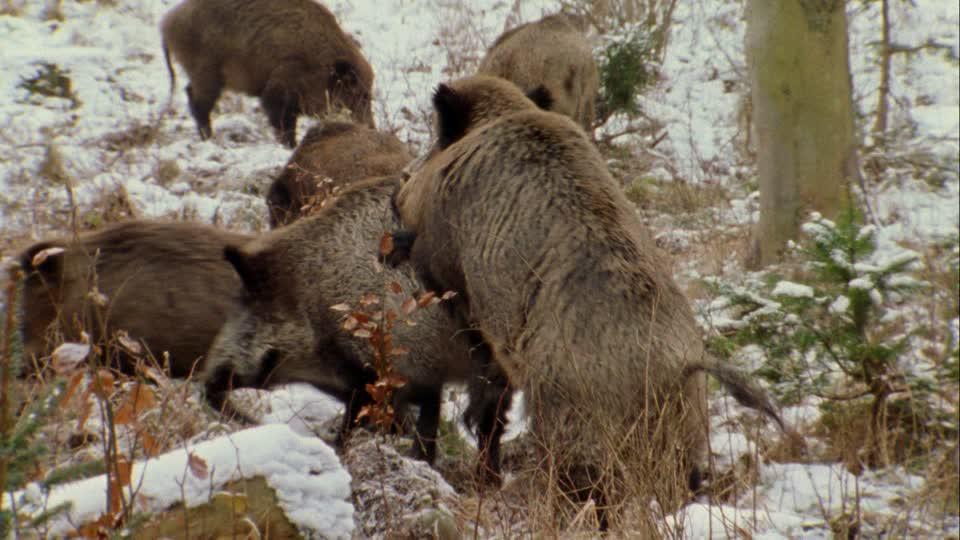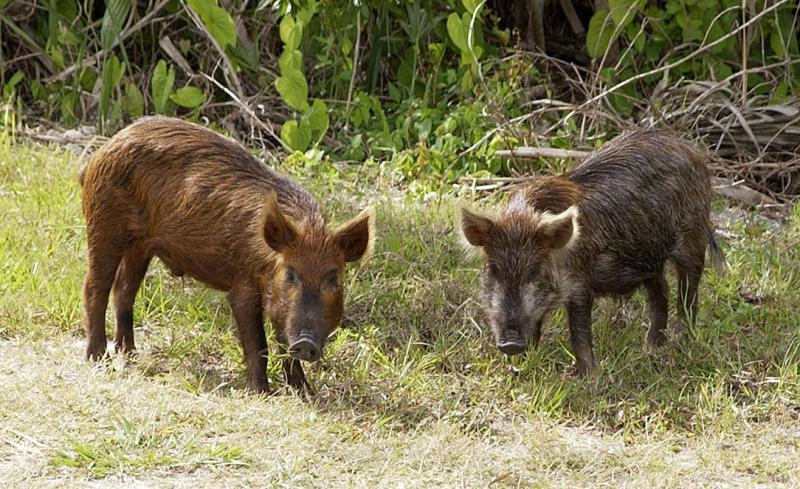The first image is the image on the left, the second image is the image on the right. Analyze the images presented: Is the assertion "There is at most three wild pigs in the right image." valid? Answer yes or no. Yes. 